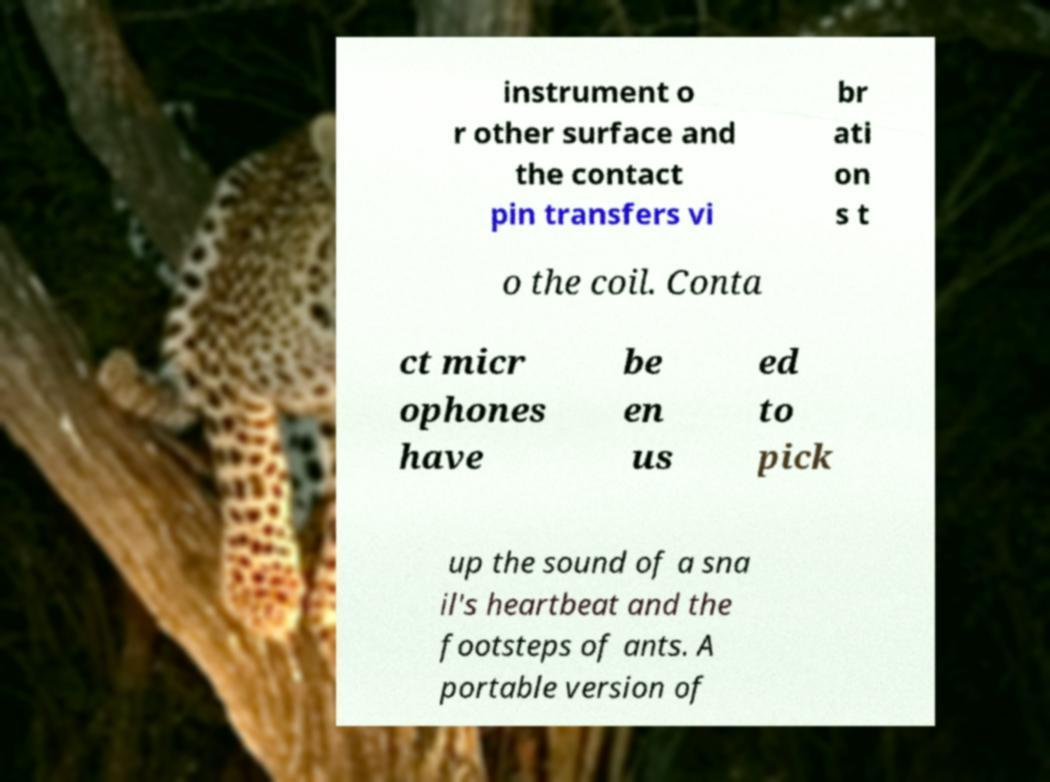Please identify and transcribe the text found in this image. instrument o r other surface and the contact pin transfers vi br ati on s t o the coil. Conta ct micr ophones have be en us ed to pick up the sound of a sna il's heartbeat and the footsteps of ants. A portable version of 